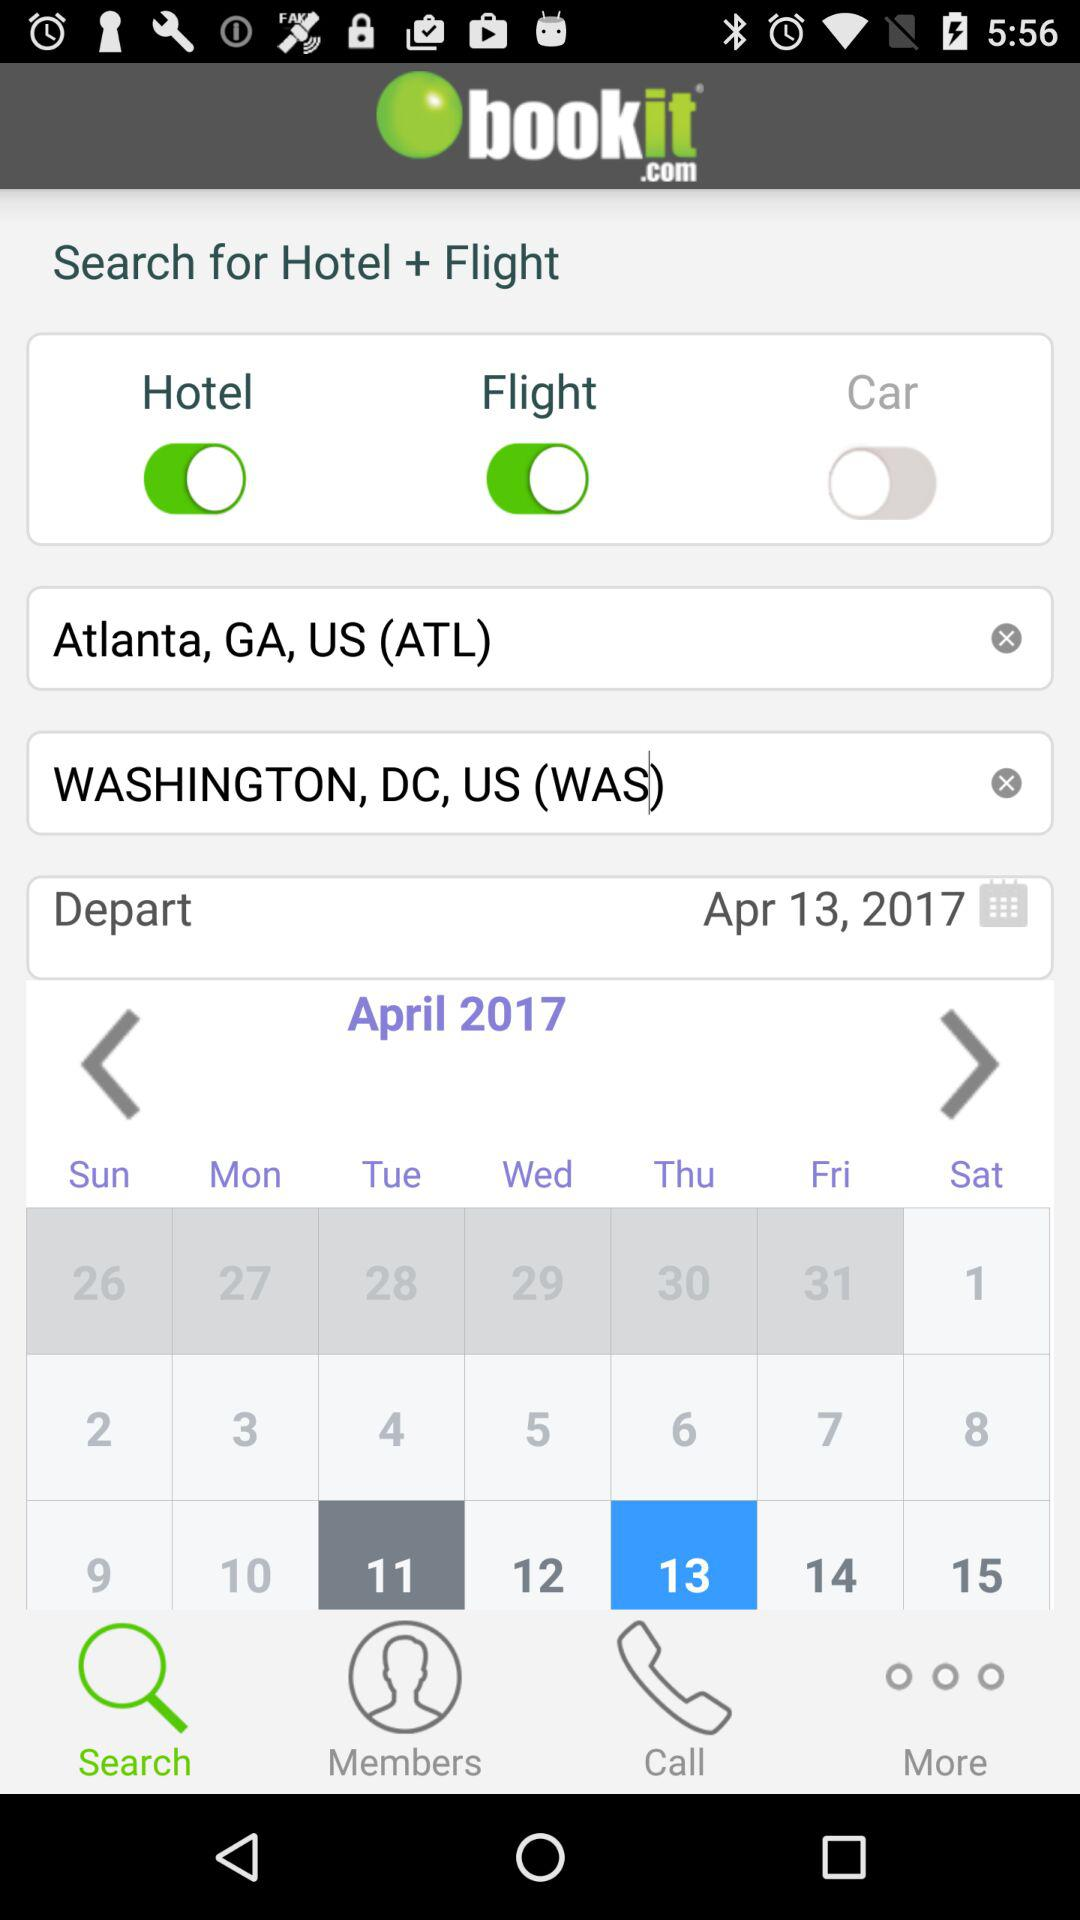What is the status of "Hotel"? The status of "Hotel" is "on". 